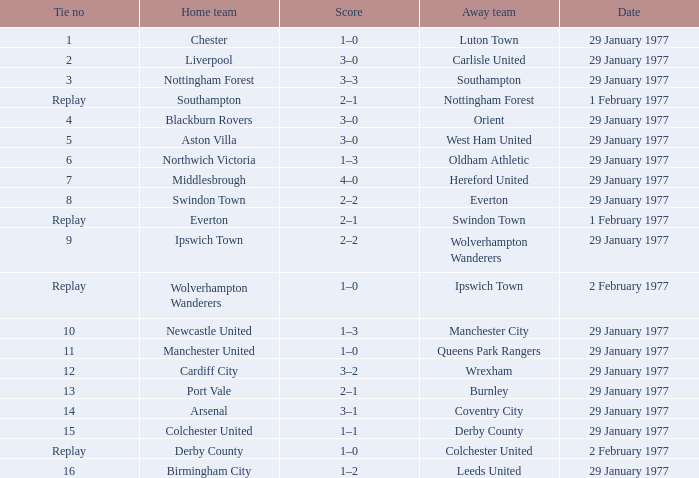What is the draw number when the home team is port vale? 13.0. 